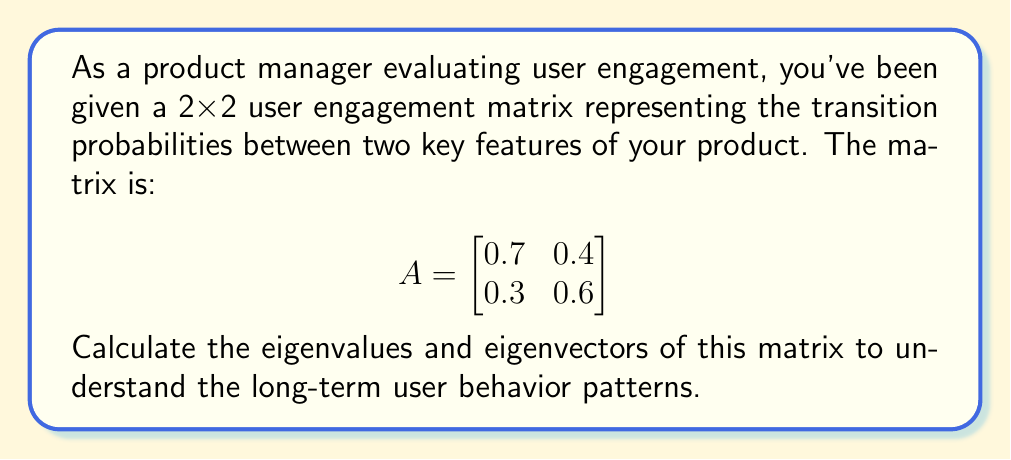Help me with this question. To find the eigenvalues and eigenvectors of matrix A, we follow these steps:

1) Find the characteristic equation:
   $det(A - \lambda I) = 0$
   
   $$\begin{vmatrix}
   0.7 - \lambda & 0.4 \\
   0.3 & 0.6 - \lambda
   \end{vmatrix} = 0$$

2) Expand the determinant:
   $(0.7 - \lambda)(0.6 - \lambda) - 0.12 = 0$
   $0.42 - 0.7\lambda - 0.6\lambda + \lambda^2 - 0.12 = 0$
   $\lambda^2 - 1.3\lambda + 0.3 = 0$

3) Solve the quadratic equation:
   Using the quadratic formula: $\lambda = \frac{-b \pm \sqrt{b^2 - 4ac}}{2a}$
   $\lambda = \frac{1.3 \pm \sqrt{1.69 - 1.2}}{2} = \frac{1.3 \pm \sqrt{0.49}}{2} = \frac{1.3 \pm 0.7}{2}$

   $\lambda_1 = 1$ and $\lambda_2 = 0.3$

4) Find the eigenvectors:
   For $\lambda_1 = 1$:
   $(A - I)v = 0$
   $$\begin{bmatrix}
   -0.3 & 0.4 \\
   0.3 & -0.4
   \end{bmatrix}\begin{bmatrix}
   v_1 \\
   v_2
   \end{bmatrix} = \begin{bmatrix}
   0 \\
   0
   \end{bmatrix}$$
   
   This gives us: $v_1 = 4$ and $v_2 = 3$
   Eigenvector for $\lambda_1$: $v_1 = \begin{bmatrix} 4 \\ 3 \end{bmatrix}$

   For $\lambda_2 = 0.3$:
   $(A - 0.3I)v = 0$
   $$\begin{bmatrix}
   0.4 & 0.4 \\
   0.3 & 0.3
   \end{bmatrix}\begin{bmatrix}
   v_1 \\
   v_2
   \end{bmatrix} = \begin{bmatrix}
   0 \\
   0
   \end{bmatrix}$$
   
   This gives us: $v_1 = -1$ and $v_2 = 1$
   Eigenvector for $\lambda_2$: $v_2 = \begin{bmatrix} -1 \\ 1 \end{bmatrix}$
Answer: Eigenvalues: $\lambda_1 = 1$, $\lambda_2 = 0.3$
Eigenvectors: $v_1 = \begin{bmatrix} 4 \\ 3 \end{bmatrix}$, $v_2 = \begin{bmatrix} -1 \\ 1 \end{bmatrix}$ 